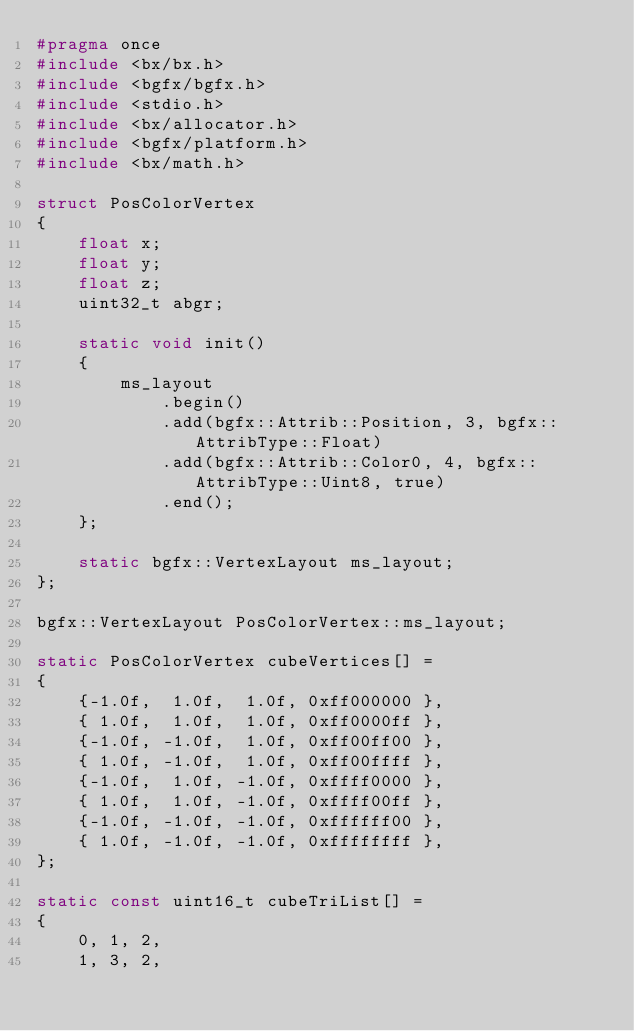Convert code to text. <code><loc_0><loc_0><loc_500><loc_500><_C_>#pragma once
#include <bx/bx.h>
#include <bgfx/bgfx.h>
#include <stdio.h>
#include <bx/allocator.h>
#include <bgfx/platform.h>
#include <bx/math.h>

struct PosColorVertex
{
    float x;
    float y;
    float z;
    uint32_t abgr;

    static void init()
    {
        ms_layout
            .begin()
            .add(bgfx::Attrib::Position, 3, bgfx::AttribType::Float)
            .add(bgfx::Attrib::Color0, 4, bgfx::AttribType::Uint8, true)
            .end();
    };

    static bgfx::VertexLayout ms_layout;
};

bgfx::VertexLayout PosColorVertex::ms_layout;

static PosColorVertex cubeVertices[] =
{
    {-1.0f,  1.0f,  1.0f, 0xff000000 },
    { 1.0f,  1.0f,  1.0f, 0xff0000ff },
    {-1.0f, -1.0f,  1.0f, 0xff00ff00 },
    { 1.0f, -1.0f,  1.0f, 0xff00ffff },
    {-1.0f,  1.0f, -1.0f, 0xffff0000 },
    { 1.0f,  1.0f, -1.0f, 0xffff00ff },
    {-1.0f, -1.0f, -1.0f, 0xffffff00 },
    { 1.0f, -1.0f, -1.0f, 0xffffffff },
};

static const uint16_t cubeTriList[] =
{
    0, 1, 2,
    1, 3, 2,</code> 